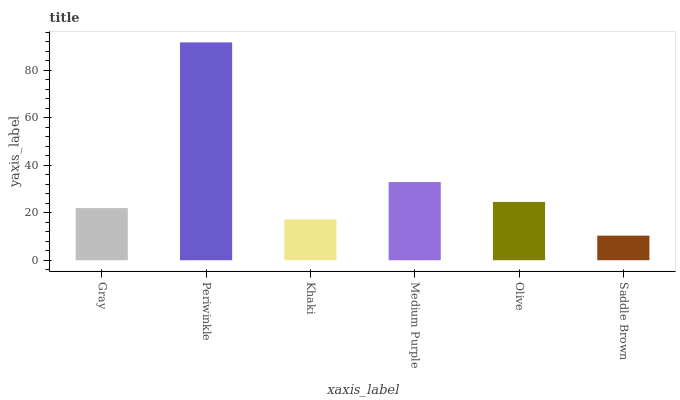Is Periwinkle the maximum?
Answer yes or no. Yes. Is Khaki the minimum?
Answer yes or no. No. Is Khaki the maximum?
Answer yes or no. No. Is Periwinkle greater than Khaki?
Answer yes or no. Yes. Is Khaki less than Periwinkle?
Answer yes or no. Yes. Is Khaki greater than Periwinkle?
Answer yes or no. No. Is Periwinkle less than Khaki?
Answer yes or no. No. Is Olive the high median?
Answer yes or no. Yes. Is Gray the low median?
Answer yes or no. Yes. Is Khaki the high median?
Answer yes or no. No. Is Periwinkle the low median?
Answer yes or no. No. 